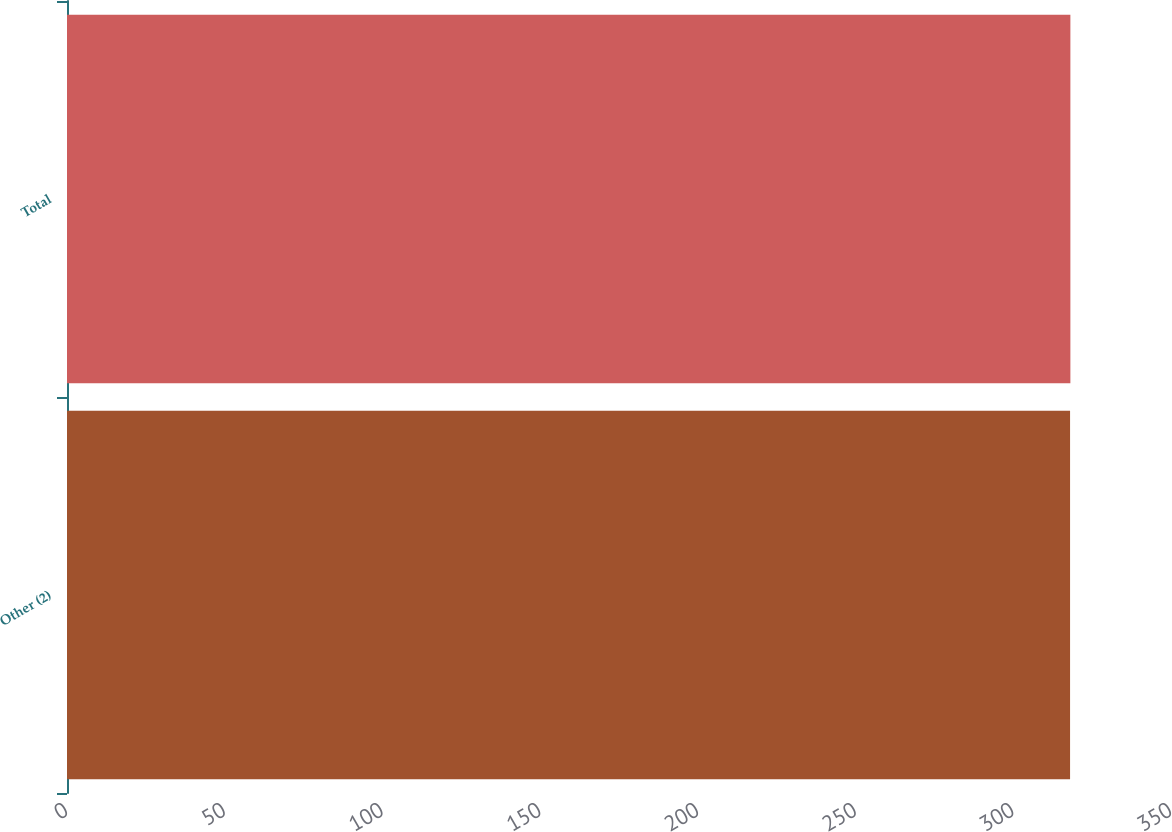Convert chart to OTSL. <chart><loc_0><loc_0><loc_500><loc_500><bar_chart><fcel>Other (2)<fcel>Total<nl><fcel>318<fcel>318.1<nl></chart> 